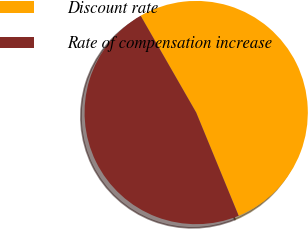Convert chart. <chart><loc_0><loc_0><loc_500><loc_500><pie_chart><fcel>Discount rate<fcel>Rate of compensation increase<nl><fcel>52.08%<fcel>47.92%<nl></chart> 